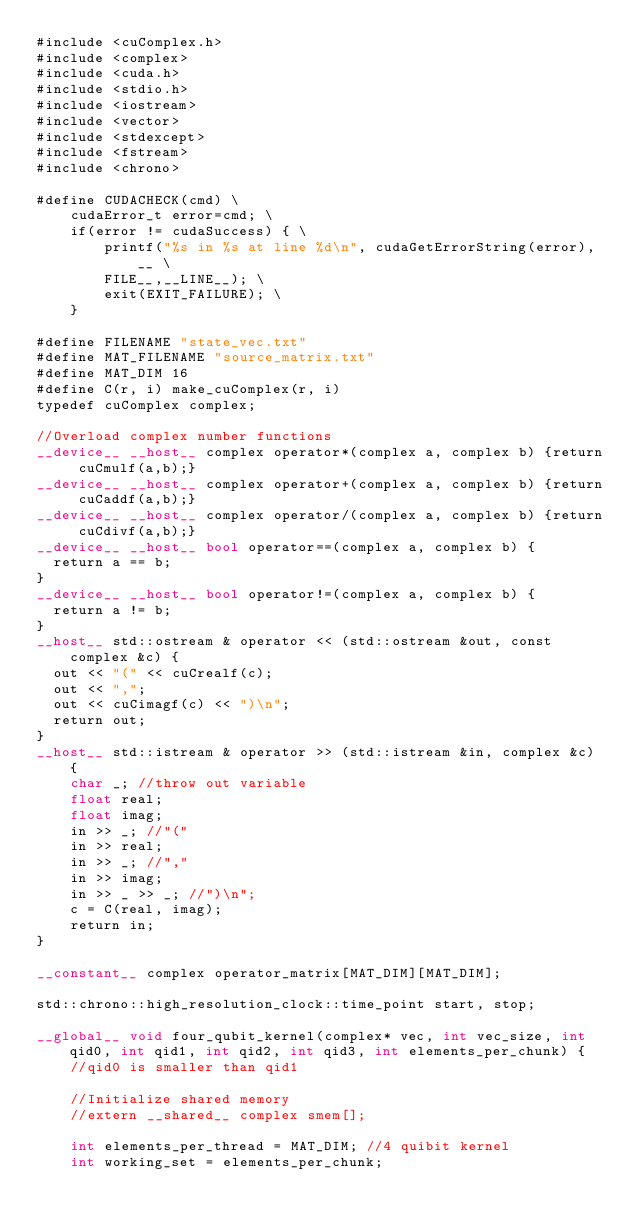<code> <loc_0><loc_0><loc_500><loc_500><_Cuda_>#include <cuComplex.h>
#include <complex>
#include <cuda.h>
#include <stdio.h>
#include <iostream>
#include <vector>
#include <stdexcept>
#include <fstream>
#include <chrono>

#define CUDACHECK(cmd) \
    cudaError_t error=cmd; \
    if(error != cudaSuccess) { \
        printf("%s in %s at line %d\n", cudaGetErrorString(error),__ \
        FILE__,__LINE__); \
        exit(EXIT_FAILURE); \
    }

#define FILENAME "state_vec.txt"
#define MAT_FILENAME "source_matrix.txt"
#define MAT_DIM 16
#define C(r, i) make_cuComplex(r, i)
typedef cuComplex complex;

//Overload complex number functions
__device__ __host__ complex operator*(complex a, complex b) {return cuCmulf(a,b);}
__device__ __host__ complex operator+(complex a, complex b) {return cuCaddf(a,b);}
__device__ __host__ complex operator/(complex a, complex b) {return cuCdivf(a,b);}
__device__ __host__ bool operator==(complex a, complex b) {
	return a == b;
}
__device__ __host__ bool operator!=(complex a, complex b) {
	return a != b;
}
__host__ std::ostream & operator << (std::ostream &out, const complex &c) {
	out << "(" << cuCrealf(c);
	out << ",";
	out << cuCimagf(c) << ")\n";
	return out;
}
__host__ std::istream & operator >> (std::istream &in, complex &c) {
    char _; //throw out variable
    float real;
    float imag;
    in >> _; //"("
    in >> real;
    in >> _; //","
    in >> imag;
    in >> _ >> _; //")\n";
    c = C(real, imag);
    return in;
}

__constant__ complex operator_matrix[MAT_DIM][MAT_DIM];

std::chrono::high_resolution_clock::time_point start, stop;

__global__ void four_qubit_kernel(complex* vec, int vec_size, int qid0, int qid1, int qid2, int qid3, int elements_per_chunk) {
    //qid0 is smaller than qid1

    //Initialize shared memory
    //extern __shared__ complex smem[];

    int elements_per_thread = MAT_DIM; //4 quibit kernel
    int working_set = elements_per_chunk;
</code> 